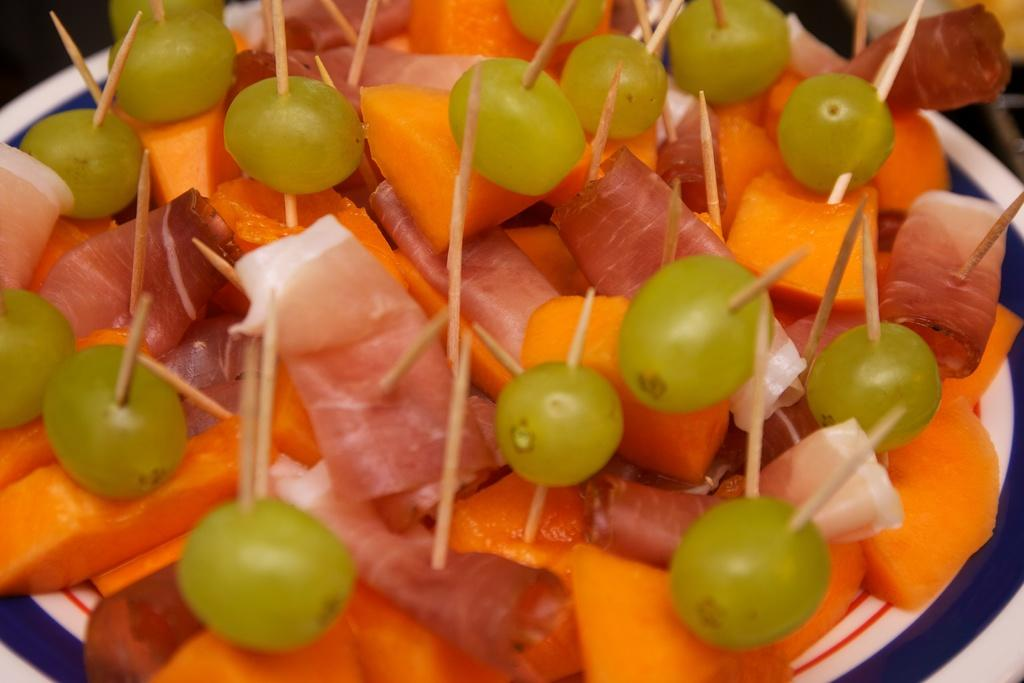What types of food are on the plate in the image? There are fruits on the plate. What other items can be seen on the plate? There is flesh and sticks on the plate. How many snails are crawling on the plate in the image? There are no snails present on the plate in the image. What type of story is being told on the plate? There is no story being told on the plate; it contains fruits, flesh, and sticks. 